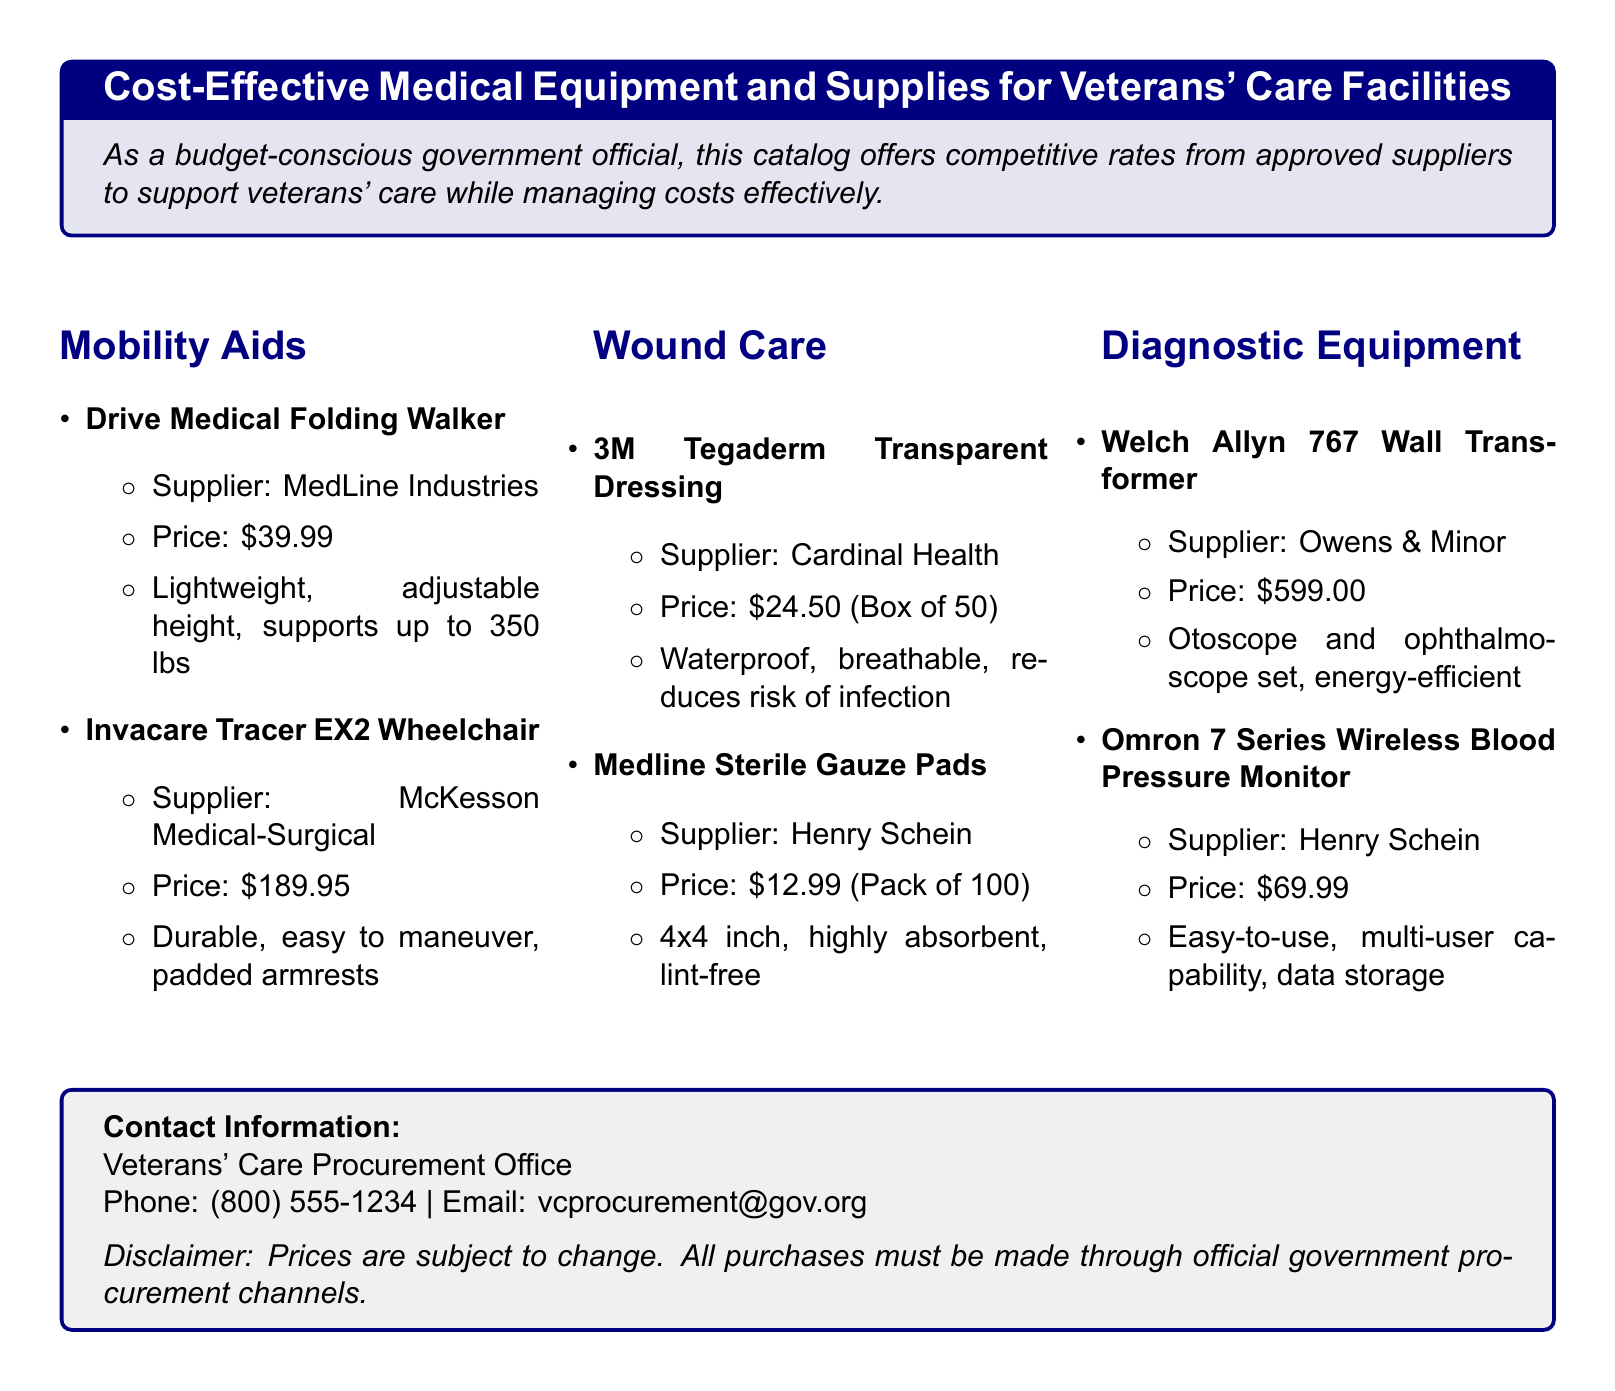What is the price of the Drive Medical Folding Walker? The price of the Drive Medical Folding Walker is listed in the mobility aids section of the document.
Answer: $39.99 Who is the supplier for the Invacare Tracer EX2 Wheelchair? The supplier's name is provided in the description for the Invacare Tracer EX2 Wheelchair in the mobility aids section.
Answer: McKesson Medical-Surgical How many Sterile Gauze Pads are in a pack? The number of pads per pack for the Medline Sterile Gauze Pads is mentioned under the wound care section.
Answer: 100 What is the price of the Omron 7 Series Wireless Blood Pressure Monitor? The price is stated next to the product name in the diagnostic equipment section.
Answer: $69.99 Which product in the catalog is waterproof? The waterproof feature is explicitly described in the product details for a wound care item.
Answer: 3M Tegaderm Transparent Dressing What is the contact phone number for the Veterans' Care Procurement Office? The contact information section provides the phone number necessary for procurement inquiries.
Answer: (800) 555-1234 Which supplier provides the Welch Allyn 767 Wall Transformer? The document lists suppliers for each product, including the Welch Allyn 767 Wall Transformer in the diagnostic equipment section.
Answer: Owens & Minor What does the Medline Sterile Gauze Pads pack size measure? The size measurement is included in the product description for Medline Sterile Gauze Pads within the wound care area.
Answer: 4x4 inch Are the prices in the catalog subject to change? This information is presented as a disclaimer at the end of the document regarding the pricing of the products.
Answer: Yes 